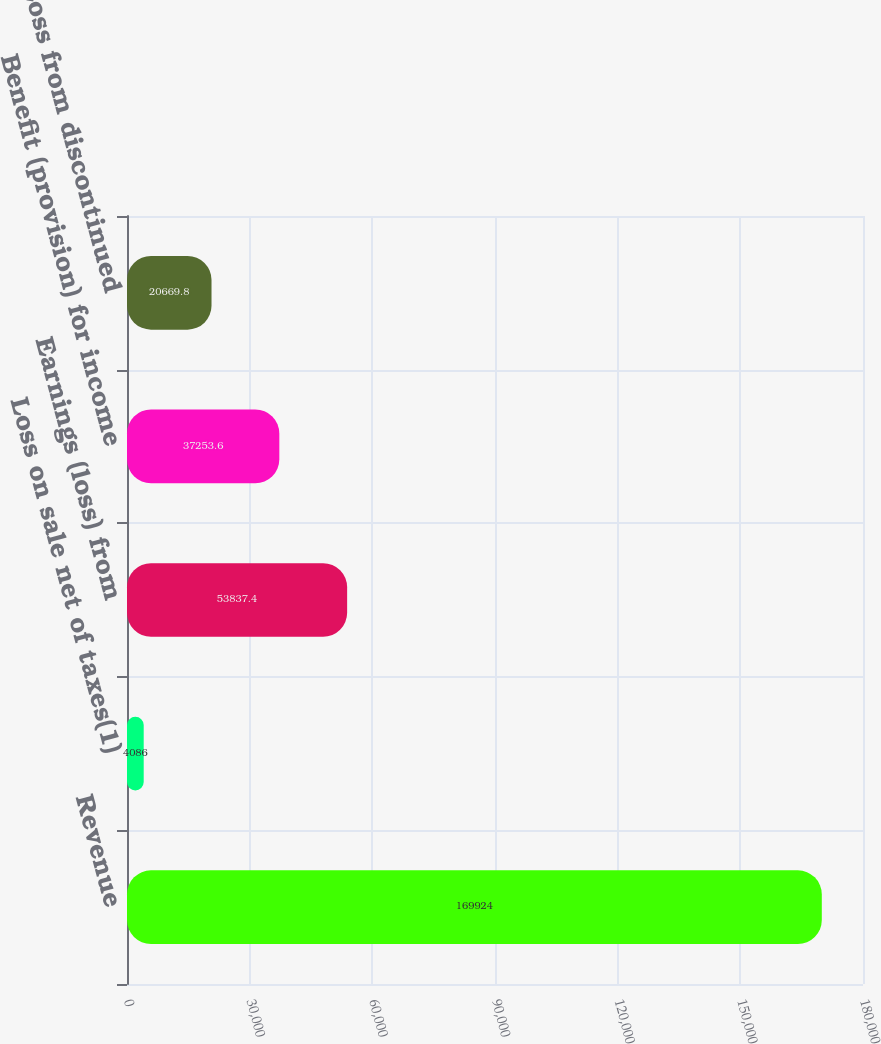<chart> <loc_0><loc_0><loc_500><loc_500><bar_chart><fcel>Revenue<fcel>Loss on sale net of taxes(1)<fcel>Earnings (loss) from<fcel>Benefit (provision) for income<fcel>Loss from discontinued<nl><fcel>169924<fcel>4086<fcel>53837.4<fcel>37253.6<fcel>20669.8<nl></chart> 